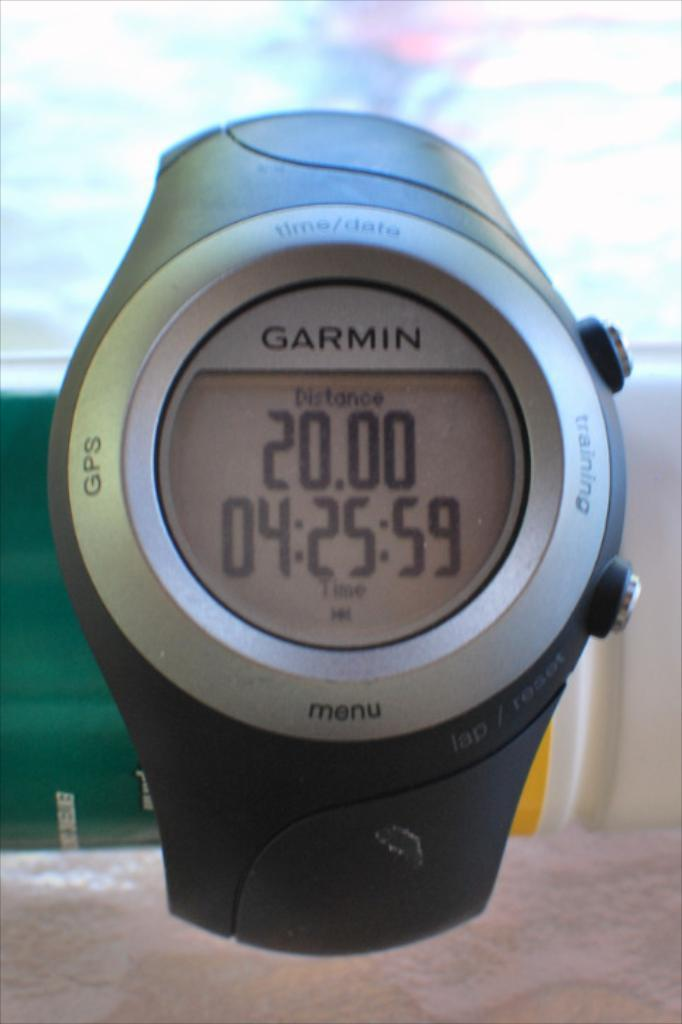<image>
Create a compact narrative representing the image presented. the number 20 is on the watch that is silver 